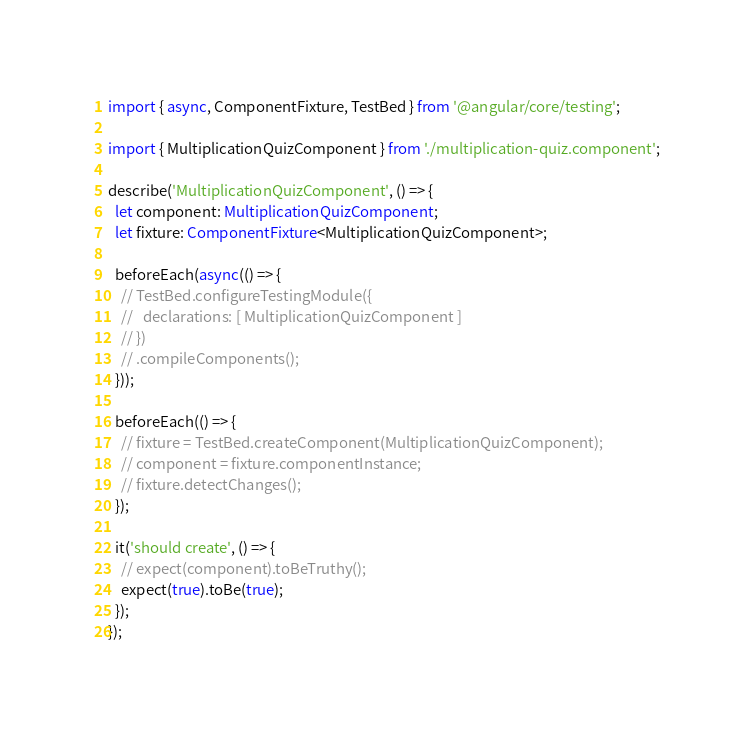<code> <loc_0><loc_0><loc_500><loc_500><_TypeScript_>import { async, ComponentFixture, TestBed } from '@angular/core/testing';

import { MultiplicationQuizComponent } from './multiplication-quiz.component';

describe('MultiplicationQuizComponent', () => {
  let component: MultiplicationQuizComponent;
  let fixture: ComponentFixture<MultiplicationQuizComponent>;

  beforeEach(async(() => {
    // TestBed.configureTestingModule({
    //   declarations: [ MultiplicationQuizComponent ]
    // })
    // .compileComponents();
  }));

  beforeEach(() => {
    // fixture = TestBed.createComponent(MultiplicationQuizComponent);
    // component = fixture.componentInstance;
    // fixture.detectChanges();
  });

  it('should create', () => {
    // expect(component).toBeTruthy();
    expect(true).toBe(true);
  });
});
</code> 